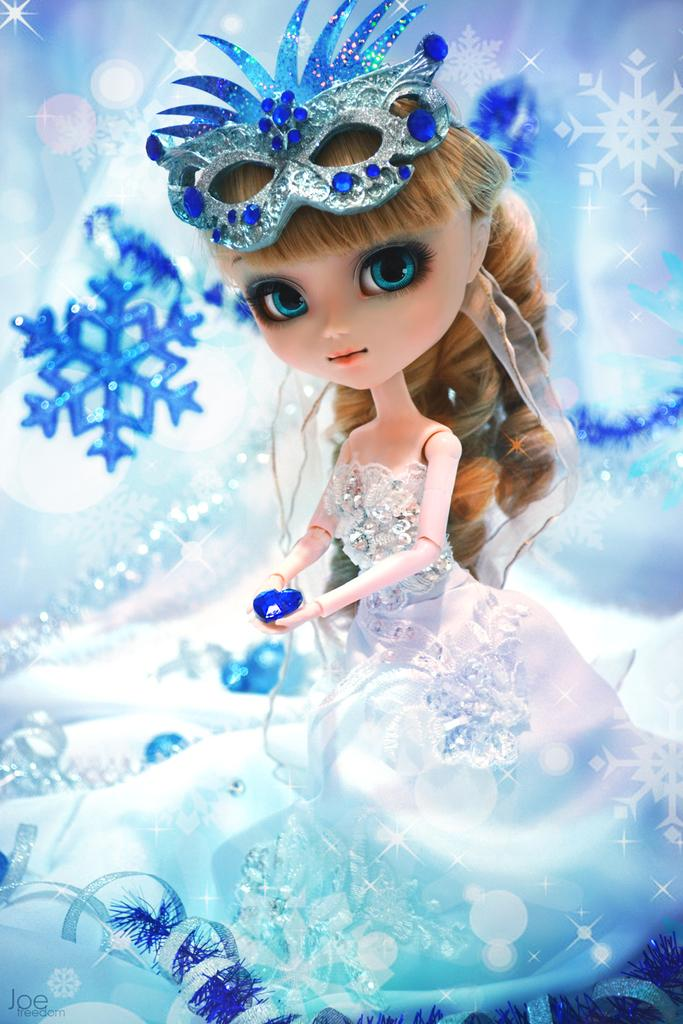What is depicted in the image? There is an animation of a girl in the image. Can you describe the girl's attire? The girl is wearing a white and sky blue color dress. Are there any plantations visible in the image? There are no plantations present in the image; it features an animation of a girl wearing a white and sky blue color dress. What type of hat is the girl wearing in the image? The girl is not wearing a hat in the image; she is wearing a white and sky blue color dress. 